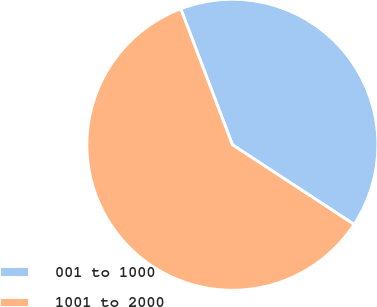Convert chart. <chart><loc_0><loc_0><loc_500><loc_500><pie_chart><fcel>001 to 1000<fcel>1001 to 2000<nl><fcel>40.0%<fcel>60.0%<nl></chart> 